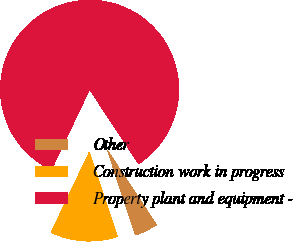<chart> <loc_0><loc_0><loc_500><loc_500><pie_chart><fcel>Other<fcel>Construction work in progress<fcel>Property plant and equipment -<nl><fcel>4.2%<fcel>12.14%<fcel>83.66%<nl></chart> 